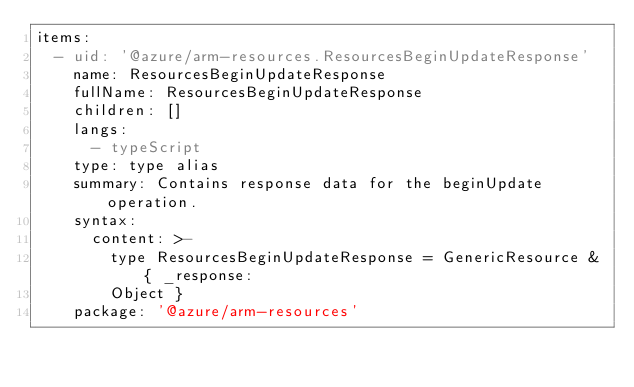<code> <loc_0><loc_0><loc_500><loc_500><_YAML_>items:
  - uid: '@azure/arm-resources.ResourcesBeginUpdateResponse'
    name: ResourcesBeginUpdateResponse
    fullName: ResourcesBeginUpdateResponse
    children: []
    langs:
      - typeScript
    type: type alias
    summary: Contains response data for the beginUpdate operation.
    syntax:
      content: >-
        type ResourcesBeginUpdateResponse = GenericResource & { _response:
        Object }
    package: '@azure/arm-resources'
</code> 